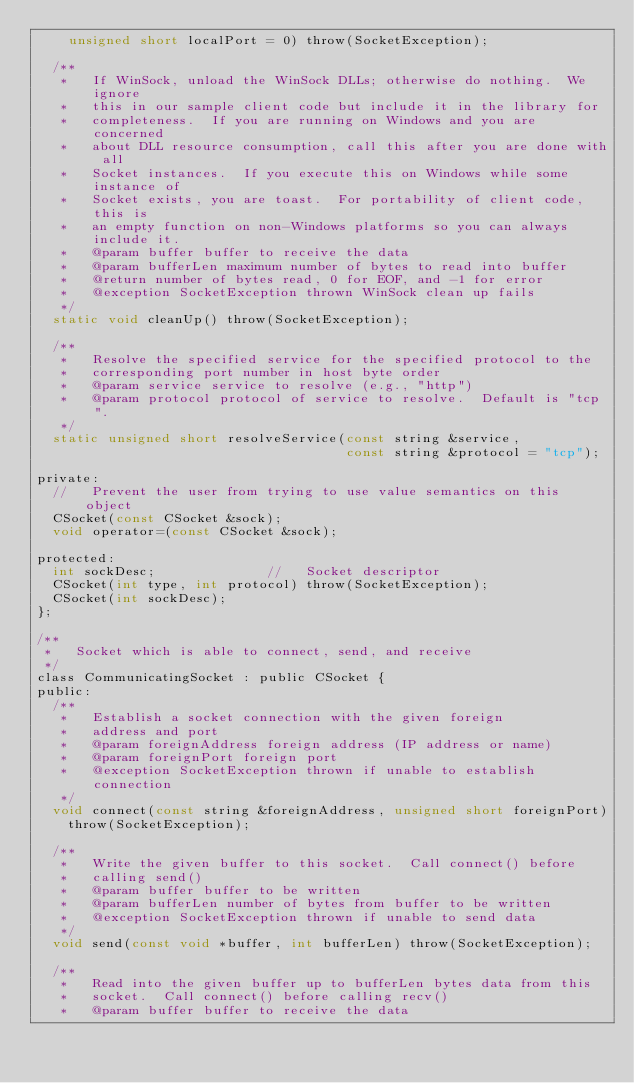<code> <loc_0><loc_0><loc_500><loc_500><_C_>    unsigned short localPort = 0) throw(SocketException);

  /**
   *   If WinSock, unload the WinSock DLLs; otherwise do nothing.  We ignore
   *   this in our sample client code but include it in the library for
   *   completeness.  If you are running on Windows and you are concerned
   *   about DLL resource consumption, call this after you are done with all
   *   Socket instances.  If you execute this on Windows while some instance of
   *   Socket exists, you are toast.  For portability of client code, this is 
   *   an empty function on non-Windows platforms so you can always include it.
   *   @param buffer buffer to receive the data
   *   @param bufferLen maximum number of bytes to read into buffer
   *   @return number of bytes read, 0 for EOF, and -1 for error
   *   @exception SocketException thrown WinSock clean up fails
   */
  static void cleanUp() throw(SocketException);

  /**
   *   Resolve the specified service for the specified protocol to the
   *   corresponding port number in host byte order
   *   @param service service to resolve (e.g., "http")
   *   @param protocol protocol of service to resolve.  Default is "tcp".
   */
  static unsigned short resolveService(const string &service,
                                       const string &protocol = "tcp");

private:
  //   Prevent the user from trying to use value semantics on this object
  CSocket(const CSocket &sock);
  void operator=(const CSocket &sock);

protected:
  int sockDesc;              //   Socket descriptor
  CSocket(int type, int protocol) throw(SocketException);
  CSocket(int sockDesc);
};

/**
 *   Socket which is able to connect, send, and receive
 */
class CommunicatingSocket : public CSocket {
public:
  /**
   *   Establish a socket connection with the given foreign
   *   address and port
   *   @param foreignAddress foreign address (IP address or name)
   *   @param foreignPort foreign port
   *   @exception SocketException thrown if unable to establish connection
   */
  void connect(const string &foreignAddress, unsigned short foreignPort)
    throw(SocketException);

  /**
   *   Write the given buffer to this socket.  Call connect() before
   *   calling send()
   *   @param buffer buffer to be written
   *   @param bufferLen number of bytes from buffer to be written
   *   @exception SocketException thrown if unable to send data
   */
  void send(const void *buffer, int bufferLen) throw(SocketException);

  /**
   *   Read into the given buffer up to bufferLen bytes data from this
   *   socket.  Call connect() before calling recv()
   *   @param buffer buffer to receive the data</code> 